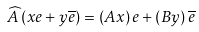Convert formula to latex. <formula><loc_0><loc_0><loc_500><loc_500>\widehat { A } \left ( x e + y \overline { e } \right ) = \left ( A x \right ) e + \left ( B y \right ) \overline { e }</formula> 